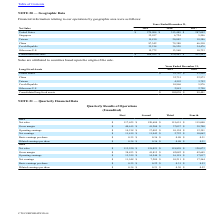From Cts Corporation's financial document, Which years does the table provide information relating to the company's operations by geographic area? The document contains multiple relevant values: 2019, 2018, 2017. From the document: "2019 2018 2017 2019 2018 2017 2019 2018 2017..." Also, What was the net sales from Other non-U.S. countries in 2019? According to the financial document, 15,772 (in thousands). The relevant text states: "Other non-U.S. 15,772 13,560 10,733..." Also, What were the consolidated net sales in 2017? According to the financial document, 422,993 (in thousands). The relevant text states: "Consolidated net sales $ 468,999 $ 470,483 $ 422,993..." Also, How many years did the net sales from Singapore exceed $10,000 thousand? Based on the analysis, there are 1 instances. The counting process: 2019. Also, can you calculate: What was the change in the net sales from United States between 2017 and 2018? Based on the calculation: 313,489-287,092, the result is 26397 (in thousands). This is based on the information: "United States $ 279,904 $ 313,489 $ 287,092 United States $ 279,904 $ 313,489 $ 287,092..." The key data points involved are: 287,092, 313,489. Also, can you calculate: What was the percentage change in consolidated net sales between 2018 and 2019? To answer this question, I need to perform calculations using the financial data. The calculation is: (468,999-470,483)/470,483, which equals -0.32 (percentage). This is based on the information: "Consolidated net sales $ 468,999 $ 470,483 $ 422,993 Consolidated net sales $ 468,999 $ 470,483 $ 422,993..." The key data points involved are: 468,999, 470,483. 